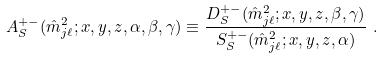Convert formula to latex. <formula><loc_0><loc_0><loc_500><loc_500>A _ { S } ^ { + - } ( \hat { m } _ { j \ell } ^ { 2 } ; x , y , z , \alpha , \beta , \gamma ) \equiv \frac { D _ { S } ^ { + - } ( \hat { m } _ { j \ell } ^ { 2 } ; x , y , z , \beta , \gamma ) } { S _ { S } ^ { + - } ( \hat { m } _ { j \ell } ^ { 2 } ; x , y , z , \alpha ) } \ .</formula> 